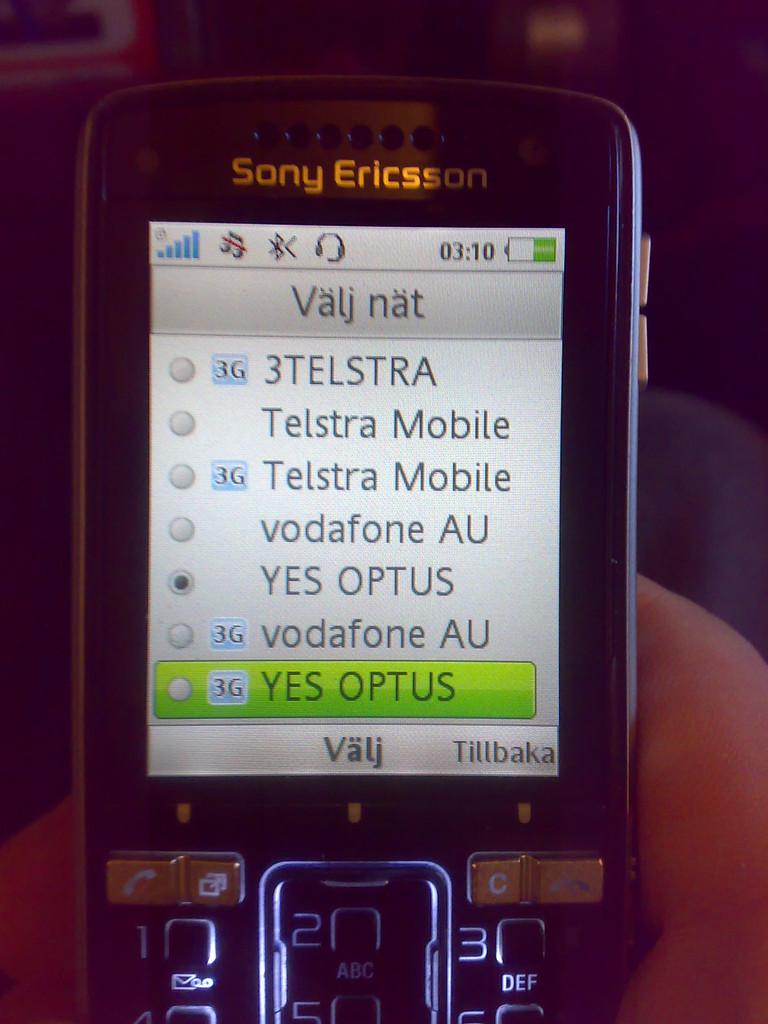At  what time was the photo taken?
Keep it short and to the point. 3:10. What kind of mobile is this?
Ensure brevity in your answer.  Sony ericsson. 